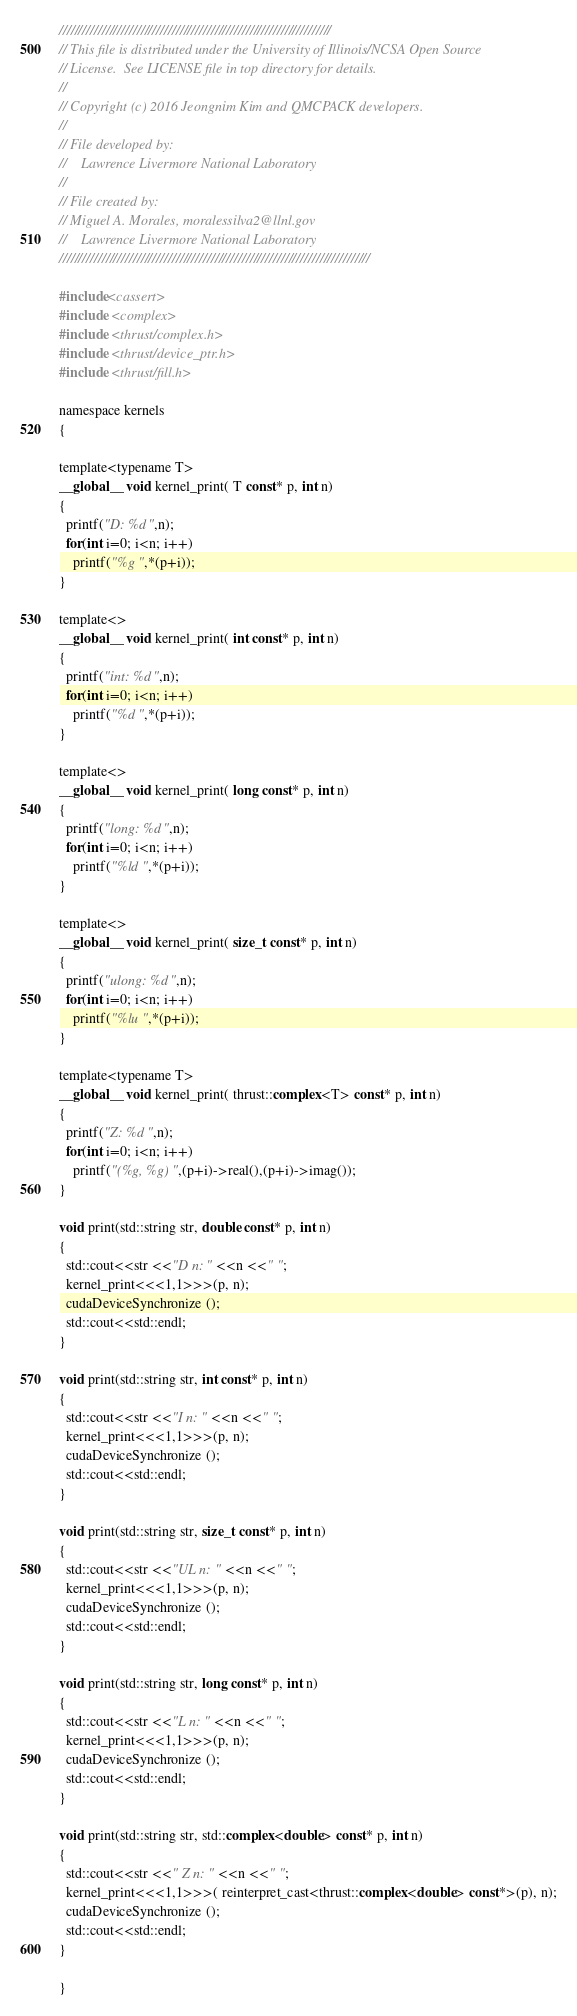<code> <loc_0><loc_0><loc_500><loc_500><_Cuda_>//////////////////////////////////////////////////////////////////////
// This file is distributed under the University of Illinois/NCSA Open Source
// License.  See LICENSE file in top directory for details.
//
// Copyright (c) 2016 Jeongnim Kim and QMCPACK developers.
//
// File developed by:
//    Lawrence Livermore National Laboratory 
//
// File created by:
// Miguel A. Morales, moralessilva2@llnl.gov 
//    Lawrence Livermore National Laboratory 
////////////////////////////////////////////////////////////////////////////////

#include<cassert>
#include <complex>
#include <thrust/complex.h>
#include <thrust/device_ptr.h>
#include <thrust/fill.h>

namespace kernels 
{

template<typename T>
__global__ void kernel_print( T const* p, int n)
{
  printf("D: %d ",n);
  for(int i=0; i<n; i++)
    printf("%g ",*(p+i));
}

template<>
__global__ void kernel_print( int const* p, int n)
{
  printf("int: %d ",n);
  for(int i=0; i<n; i++)
    printf("%d ",*(p+i));
}

template<>
__global__ void kernel_print( long const* p, int n)
{
  printf("long: %d ",n);
  for(int i=0; i<n; i++)
    printf("%ld ",*(p+i));
}

template<>
__global__ void kernel_print( size_t const* p, int n)
{
  printf("ulong: %d ",n);
  for(int i=0; i<n; i++)
    printf("%lu ",*(p+i));
}

template<typename T>
__global__ void kernel_print( thrust::complex<T> const* p, int n) 
{
  printf("Z: %d ",n);
  for(int i=0; i<n; i++)
    printf("(%g, %g) ",(p+i)->real(),(p+i)->imag());
}

void print(std::string str, double const* p, int n)
{
  std::cout<<str <<"D n: " <<n <<" "; 
  kernel_print<<<1,1>>>(p, n);
  cudaDeviceSynchronize ();
  std::cout<<std::endl;
}

void print(std::string str, int const* p, int n)
{
  std::cout<<str <<"I n: " <<n <<" "; 
  kernel_print<<<1,1>>>(p, n);
  cudaDeviceSynchronize ();
  std::cout<<std::endl;
}

void print(std::string str, size_t const* p, int n)
{
  std::cout<<str <<"UL n: " <<n <<" ";
  kernel_print<<<1,1>>>(p, n);
  cudaDeviceSynchronize ();
  std::cout<<std::endl;
}

void print(std::string str, long const* p, int n)
{
  std::cout<<str <<"L n: " <<n <<" ";
  kernel_print<<<1,1>>>(p, n);
  cudaDeviceSynchronize ();
  std::cout<<std::endl;
}

void print(std::string str, std::complex<double> const* p, int n)
{
  std::cout<<str <<" Z n: " <<n <<" "; 
  kernel_print<<<1,1>>>( reinterpret_cast<thrust::complex<double> const*>(p), n);
  cudaDeviceSynchronize ();
  std::cout<<std::endl;
}

}
</code> 